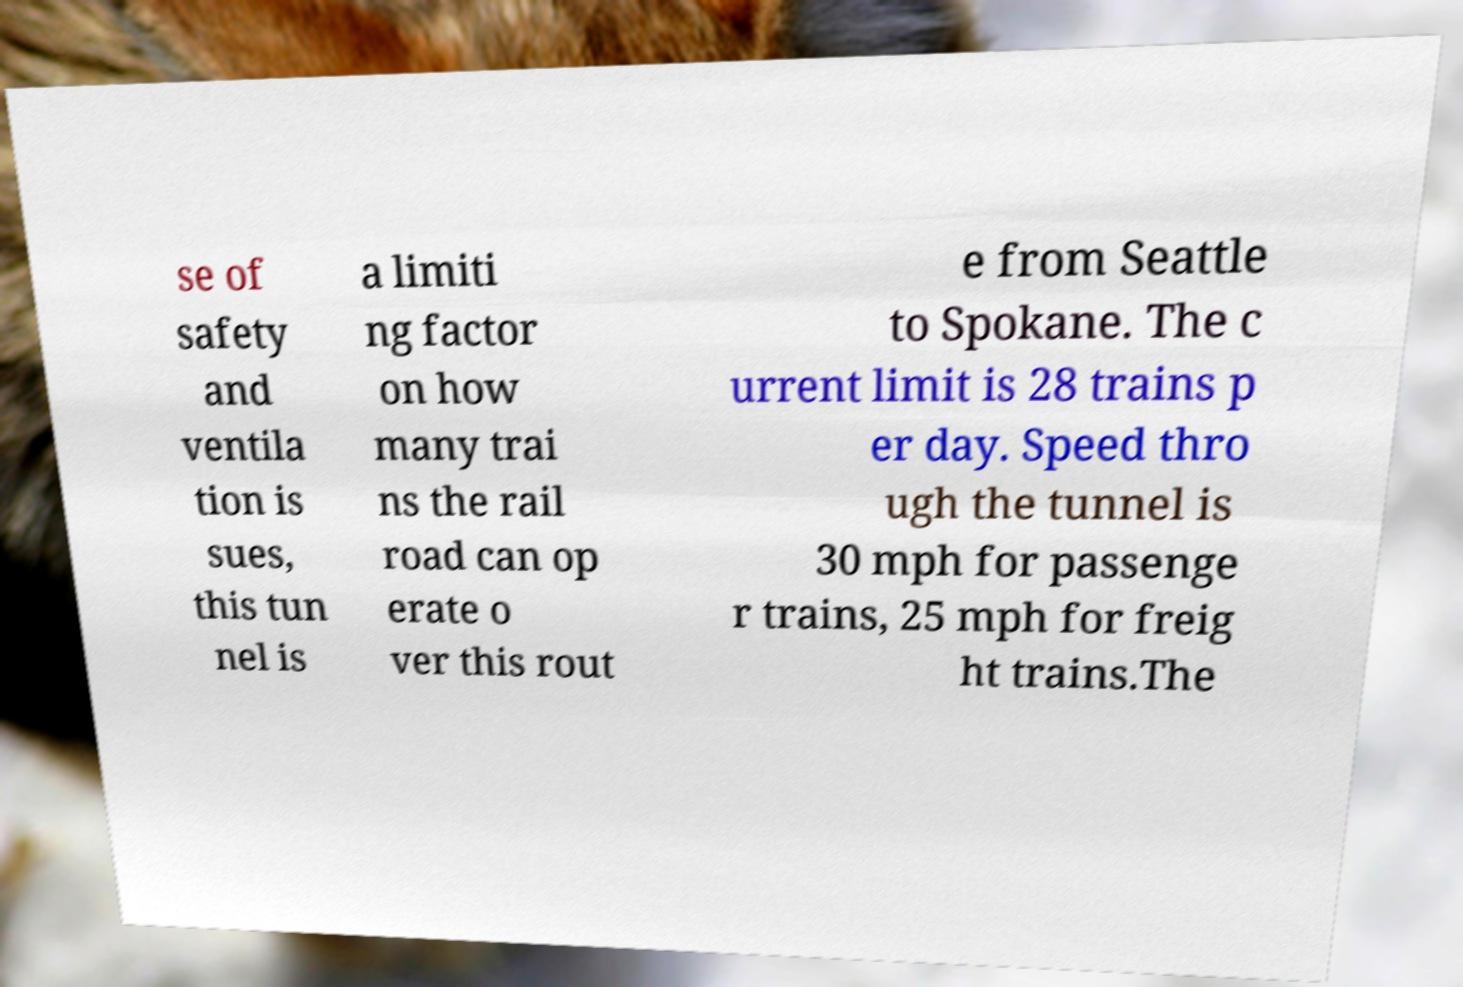I need the written content from this picture converted into text. Can you do that? se of safety and ventila tion is sues, this tun nel is a limiti ng factor on how many trai ns the rail road can op erate o ver this rout e from Seattle to Spokane. The c urrent limit is 28 trains p er day. Speed thro ugh the tunnel is 30 mph for passenge r trains, 25 mph for freig ht trains.The 